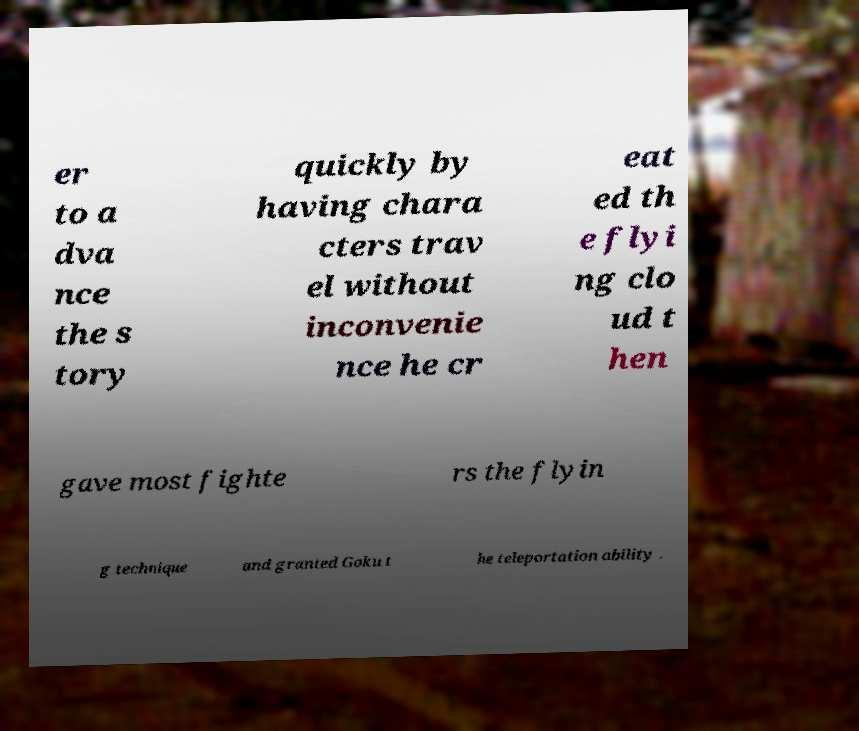Can you accurately transcribe the text from the provided image for me? er to a dva nce the s tory quickly by having chara cters trav el without inconvenie nce he cr eat ed th e flyi ng clo ud t hen gave most fighte rs the flyin g technique and granted Goku t he teleportation ability . 